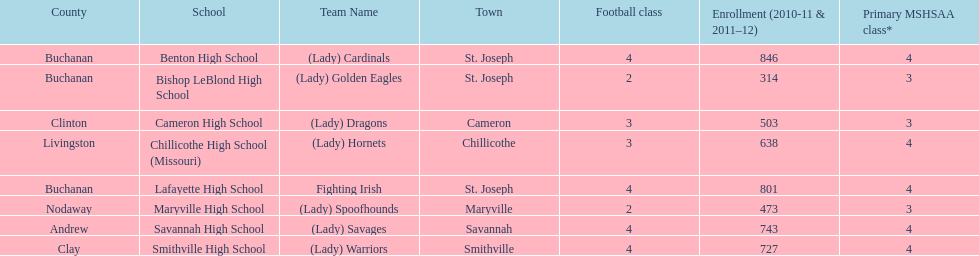What is the number of football classes lafayette high school has? 4. 